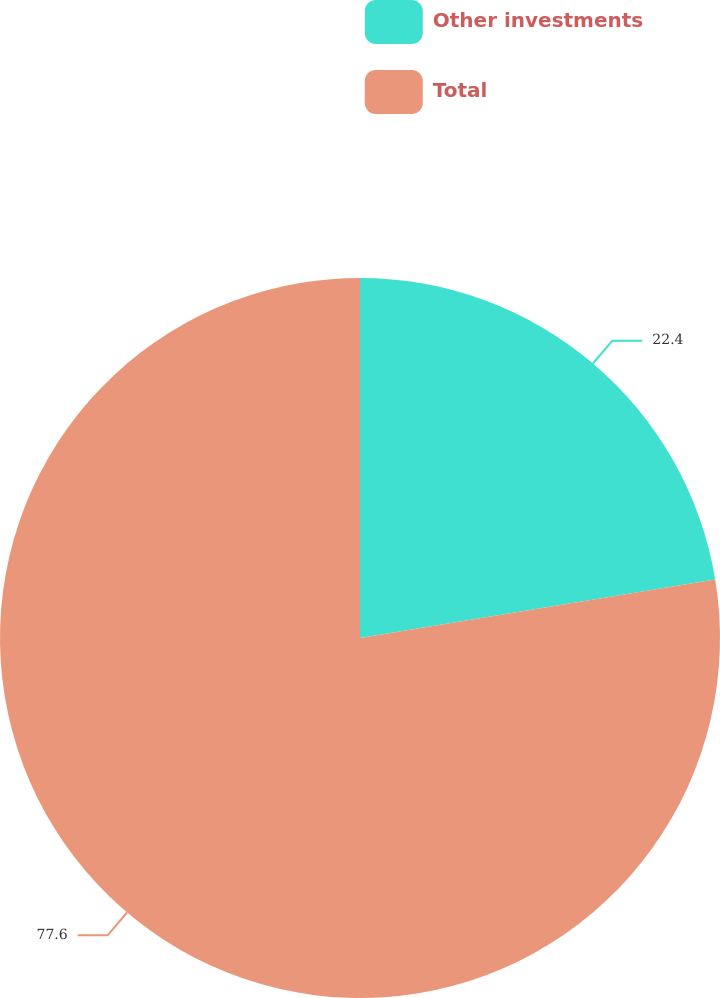<chart> <loc_0><loc_0><loc_500><loc_500><pie_chart><fcel>Other investments<fcel>Total<nl><fcel>22.4%<fcel>77.6%<nl></chart> 